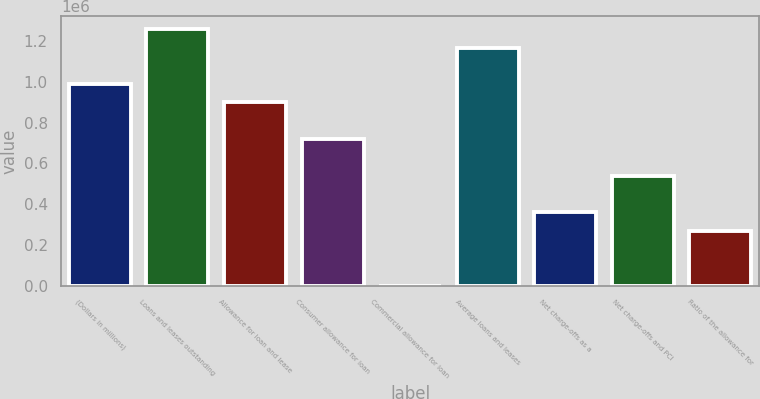Convert chart to OTSL. <chart><loc_0><loc_0><loc_500><loc_500><bar_chart><fcel>(Dollars in millions)<fcel>Loans and leases outstanding<fcel>Allowance for loan and lease<fcel>Consumer allowance for loan<fcel>Commercial allowance for loan<fcel>Average loans and leases<fcel>Net charge-offs as a<fcel>Net charge-offs and PCI<fcel>Ratio of the allowance for<nl><fcel>988699<fcel>1.25834e+06<fcel>898817<fcel>719054<fcel>0.9<fcel>1.16846e+06<fcel>359527<fcel>539291<fcel>269646<nl></chart> 